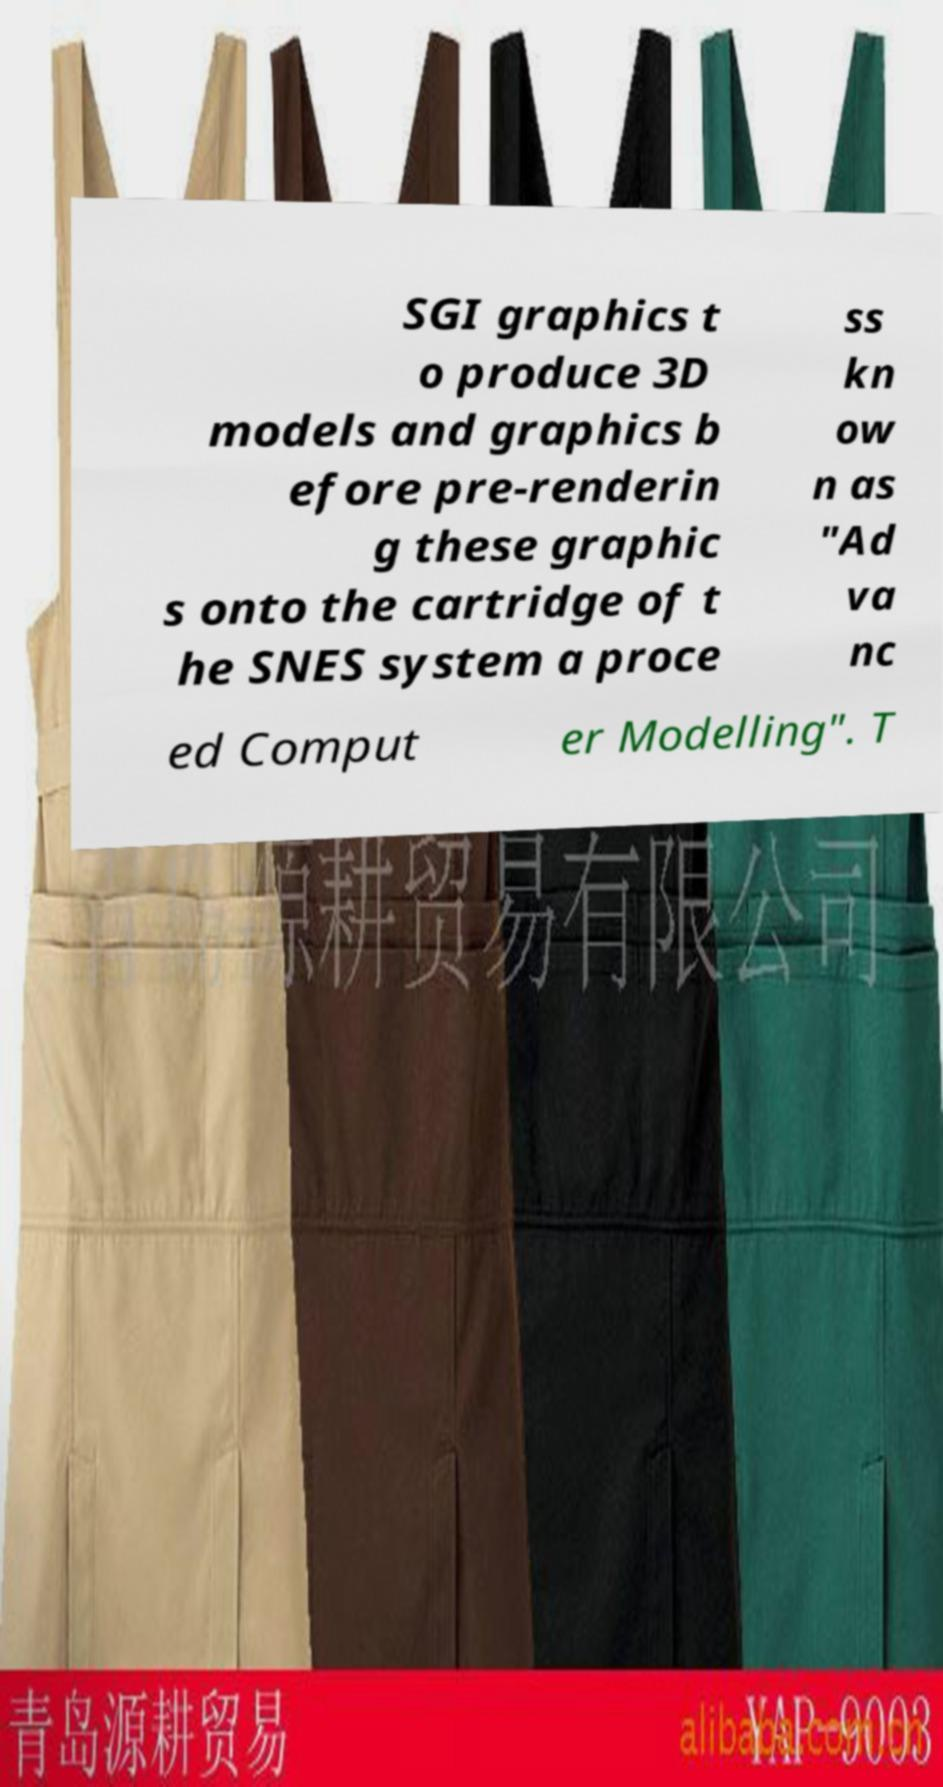Could you assist in decoding the text presented in this image and type it out clearly? SGI graphics t o produce 3D models and graphics b efore pre-renderin g these graphic s onto the cartridge of t he SNES system a proce ss kn ow n as "Ad va nc ed Comput er Modelling". T 